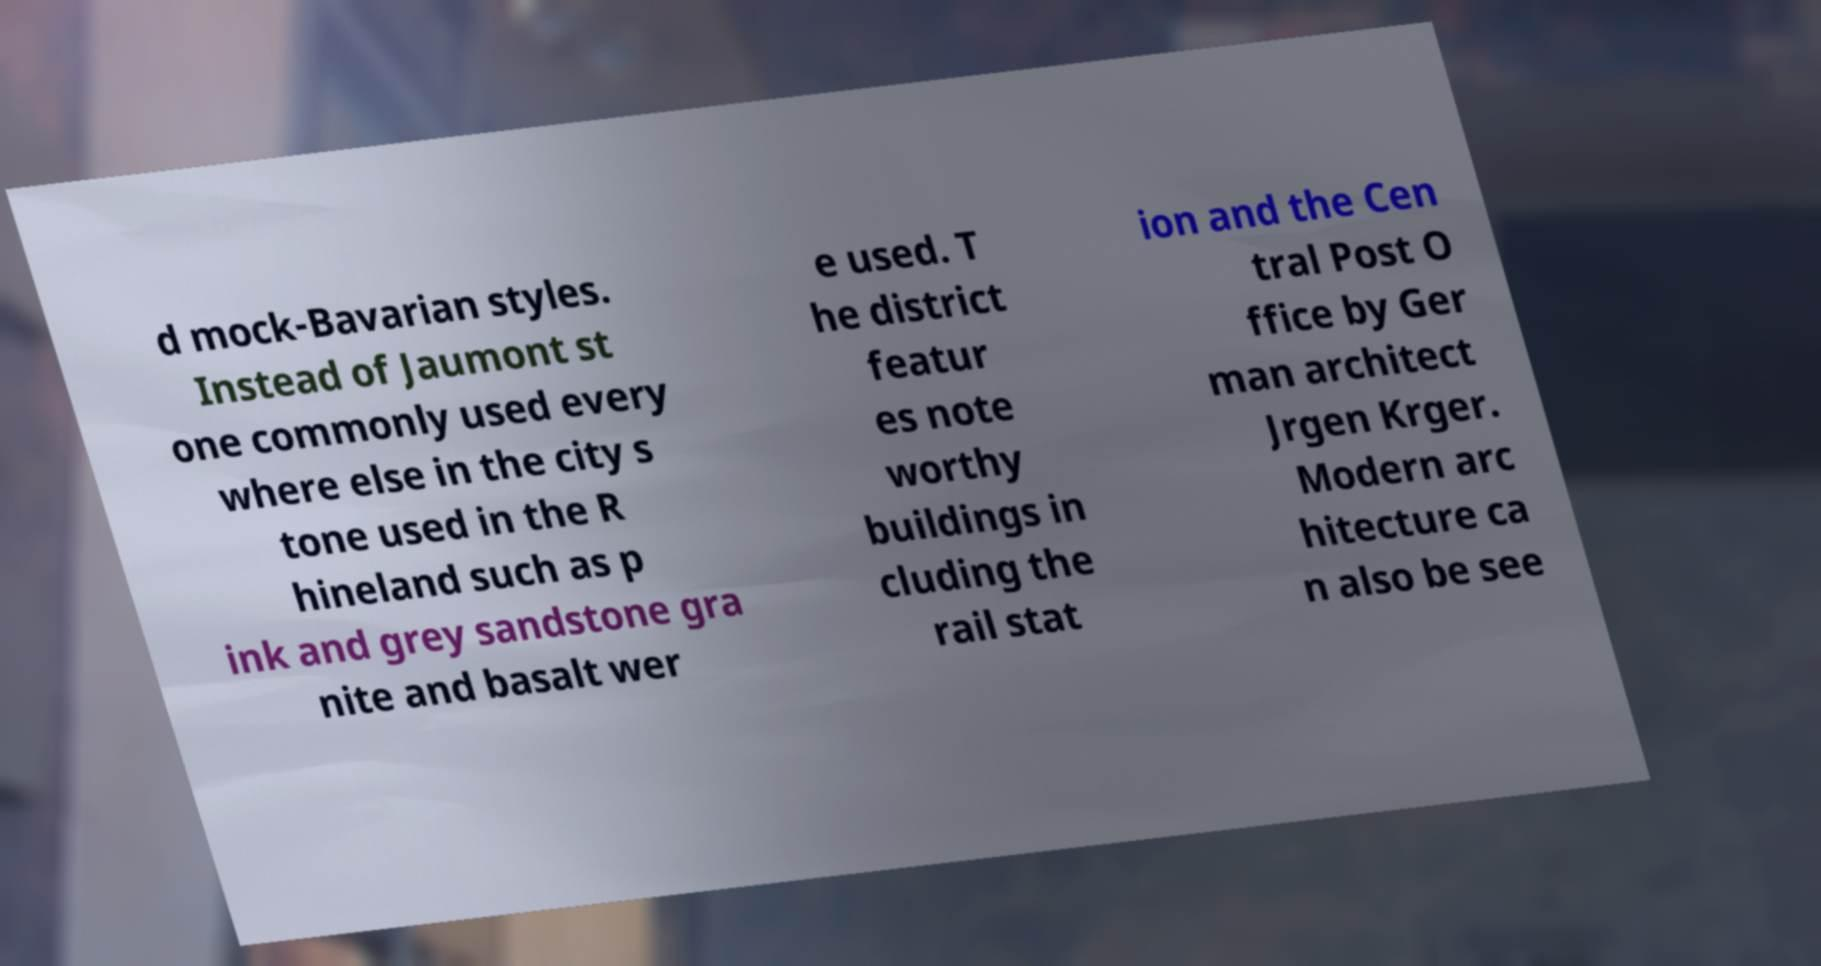Can you read and provide the text displayed in the image?This photo seems to have some interesting text. Can you extract and type it out for me? d mock-Bavarian styles. Instead of Jaumont st one commonly used every where else in the city s tone used in the R hineland such as p ink and grey sandstone gra nite and basalt wer e used. T he district featur es note worthy buildings in cluding the rail stat ion and the Cen tral Post O ffice by Ger man architect Jrgen Krger. Modern arc hitecture ca n also be see 